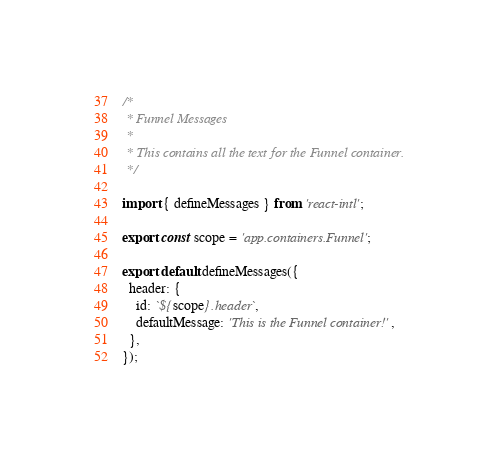Convert code to text. <code><loc_0><loc_0><loc_500><loc_500><_JavaScript_>/*
 * Funnel Messages
 *
 * This contains all the text for the Funnel container.
 */

import { defineMessages } from 'react-intl';

export const scope = 'app.containers.Funnel';

export default defineMessages({
  header: {
    id: `${scope}.header`,
    defaultMessage: 'This is the Funnel container!',
  },
});
</code> 